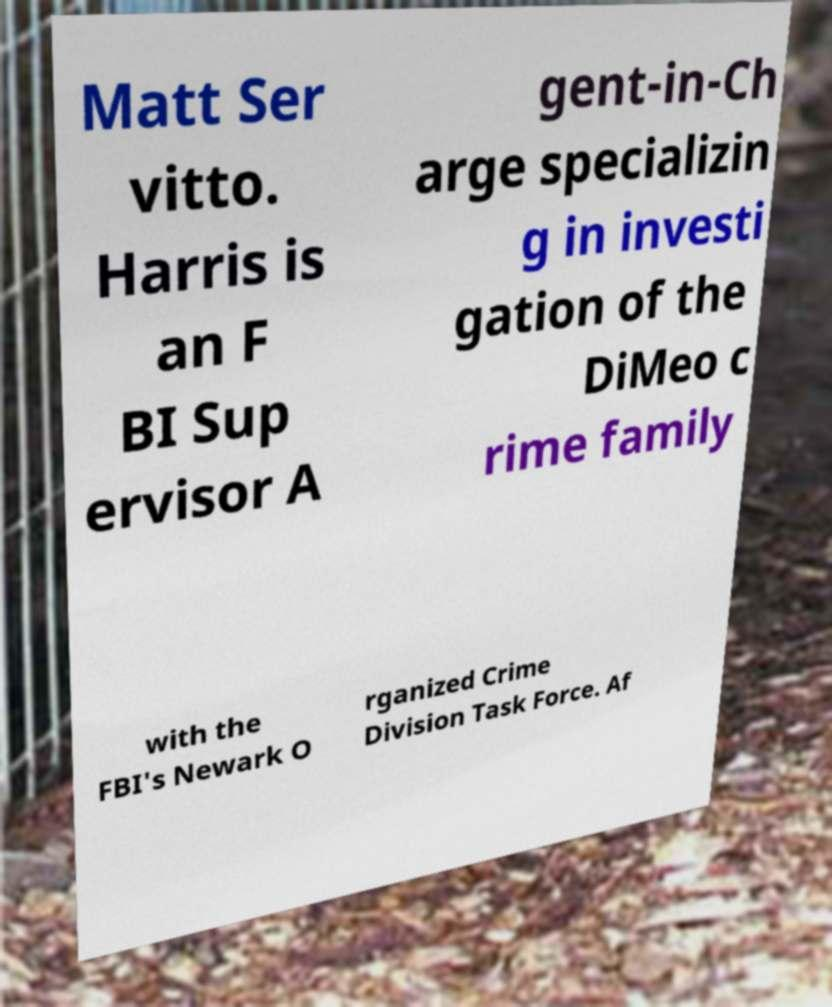For documentation purposes, I need the text within this image transcribed. Could you provide that? Matt Ser vitto. Harris is an F BI Sup ervisor A gent-in-Ch arge specializin g in investi gation of the DiMeo c rime family with the FBI's Newark O rganized Crime Division Task Force. Af 